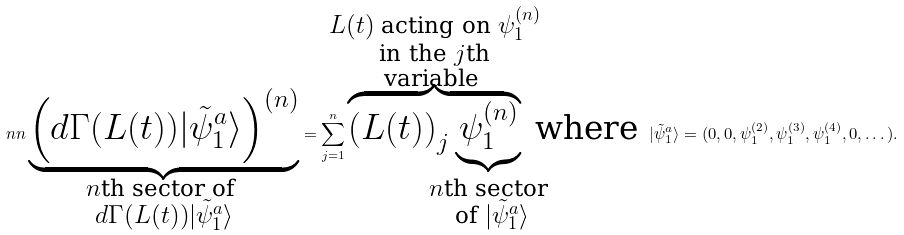<formula> <loc_0><loc_0><loc_500><loc_500>\ n n \underbrace { \left ( d \Gamma ( L ( t ) ) | \tilde { \psi } _ { 1 } ^ { a } \rangle \right ) ^ { ( n ) } } _ { \mathclap { \substack { n \text {th sector of } \\ d \Gamma ( L ( t ) ) | \tilde { \psi } _ { 1 } ^ { a } \rangle } } } = \sum _ { j = 1 } ^ { n } \overbrace { \left ( L ( t ) \right ) _ { j } \underbrace { \psi _ { 1 } ^ { ( n ) } } _ { \mathclap { \substack { n \text {th sector} \\ \text { of } | \tilde { \psi } _ { 1 } ^ { a } \rangle } } } } ^ { \mathclap { \substack { L ( t ) \text { acting on } \psi _ { 1 } ^ { ( n ) } \\ \text {in the } j \text {th} \\ \text {variable } } } } \text { where } | \tilde { \psi } _ { 1 } ^ { a } \rangle = ( 0 , 0 , \psi _ { 1 } ^ { ( 2 ) } , \psi _ { 1 } ^ { ( 3 ) } , \psi _ { 1 } ^ { ( 4 ) } , 0 , \dots ) .</formula> 